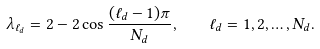<formula> <loc_0><loc_0><loc_500><loc_500>\lambda _ { \ell _ { d } } = 2 - 2 \cos \frac { ( \ell _ { d } - 1 ) \pi } { N _ { d } } , \quad \ell _ { d } = 1 , 2 , \dots , N _ { d } .</formula> 